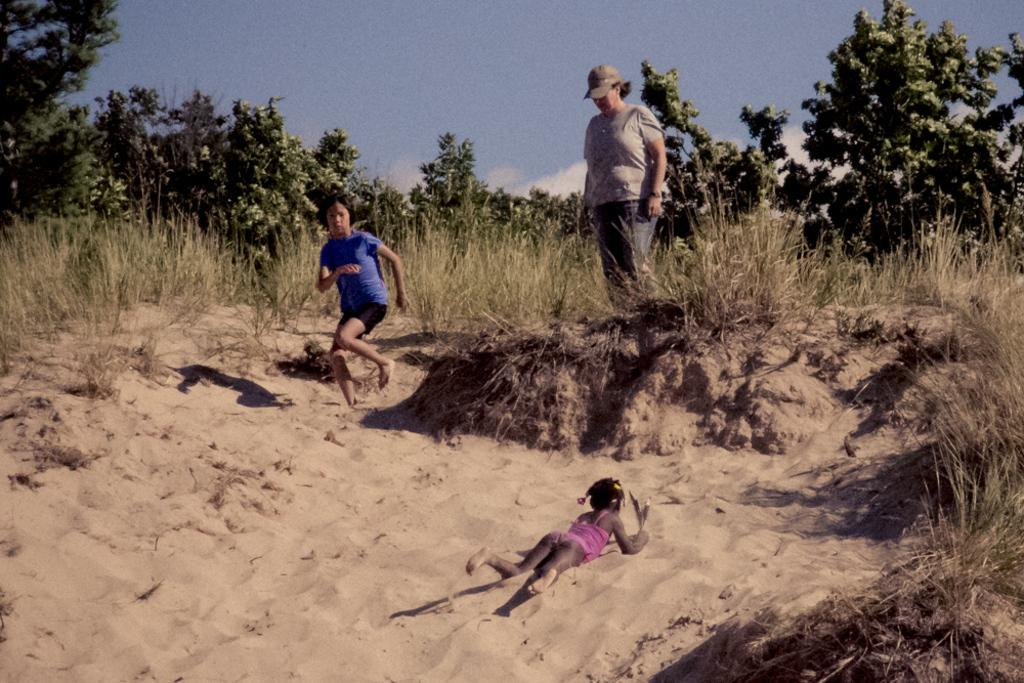What is the kid doing in the image? The kid is lying on the sand in the image. How many persons are standing in the image? There are two persons standing in the image. What type of vegetation can be seen in the image? There is grass and trees in the image. What can be seen in the background of the image? The sky is visible in the background of the image. What type of skin condition can be seen on the kid's face in the image? There is no indication of any skin condition on the kid's face in the image. What impulse might have caused the two persons to stand in the image? There is no information provided about the reasons for the two persons standing in the image, so we cannot determine any impulses that might have caused them to do so. 